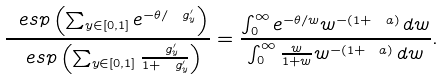Convert formula to latex. <formula><loc_0><loc_0><loc_500><loc_500>\frac { \ e s p \left ( \sum _ { y \in [ 0 , 1 ] } e ^ { - \theta / \ g ^ { \prime } _ { y } } \right ) } { \ e s p \left ( \sum _ { y \in [ 0 , 1 ] } \frac { \ g ^ { \prime } _ { y } } { 1 + \ g ^ { \prime } _ { y } } \right ) } = \frac { \int _ { 0 } ^ { \infty } e ^ { - \theta / w } w ^ { - ( 1 + \ a ) } \, d w } { \int _ { 0 } ^ { \infty } \frac { w } { 1 + w } w ^ { - ( 1 + \ a ) } \, d w } .</formula> 